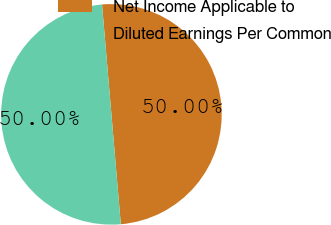Convert chart to OTSL. <chart><loc_0><loc_0><loc_500><loc_500><pie_chart><fcel>Net Income Applicable to<fcel>Diluted Earnings Per Common<nl><fcel>50.0%<fcel>50.0%<nl></chart> 